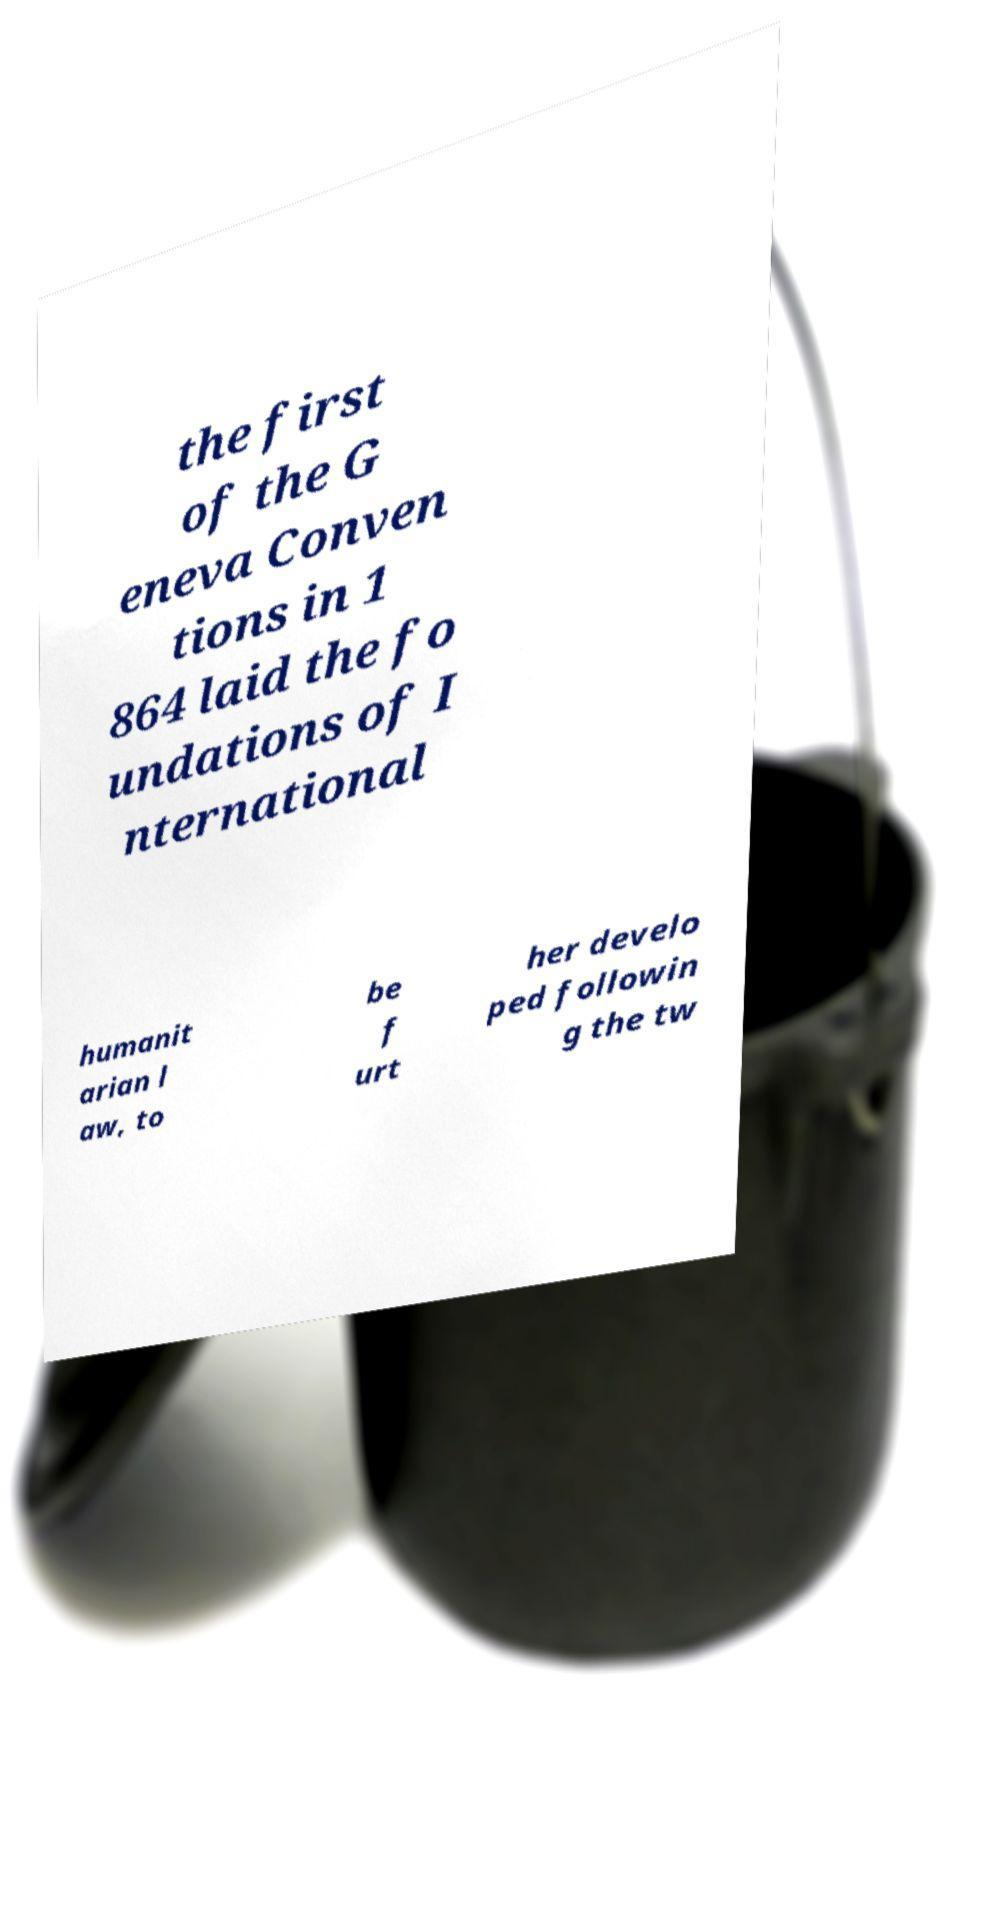Can you accurately transcribe the text from the provided image for me? the first of the G eneva Conven tions in 1 864 laid the fo undations of I nternational humanit arian l aw, to be f urt her develo ped followin g the tw 